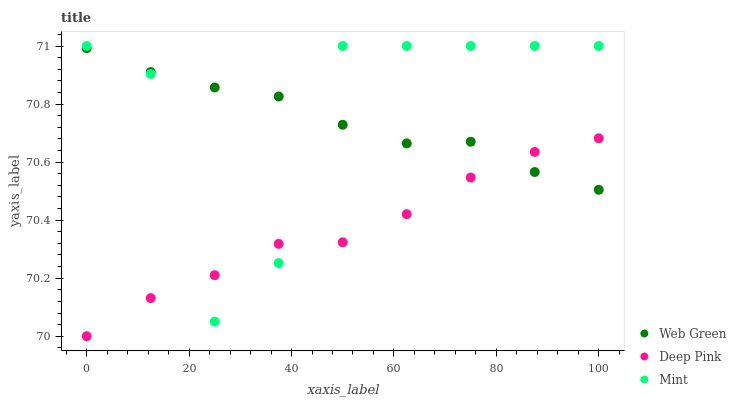Does Deep Pink have the minimum area under the curve?
Answer yes or no. Yes. Does Mint have the maximum area under the curve?
Answer yes or no. Yes. Does Web Green have the minimum area under the curve?
Answer yes or no. No. Does Web Green have the maximum area under the curve?
Answer yes or no. No. Is Web Green the smoothest?
Answer yes or no. Yes. Is Mint the roughest?
Answer yes or no. Yes. Is Mint the smoothest?
Answer yes or no. No. Is Web Green the roughest?
Answer yes or no. No. Does Deep Pink have the lowest value?
Answer yes or no. Yes. Does Mint have the lowest value?
Answer yes or no. No. Does Mint have the highest value?
Answer yes or no. Yes. Does Web Green have the highest value?
Answer yes or no. No. Does Deep Pink intersect Mint?
Answer yes or no. Yes. Is Deep Pink less than Mint?
Answer yes or no. No. Is Deep Pink greater than Mint?
Answer yes or no. No. 